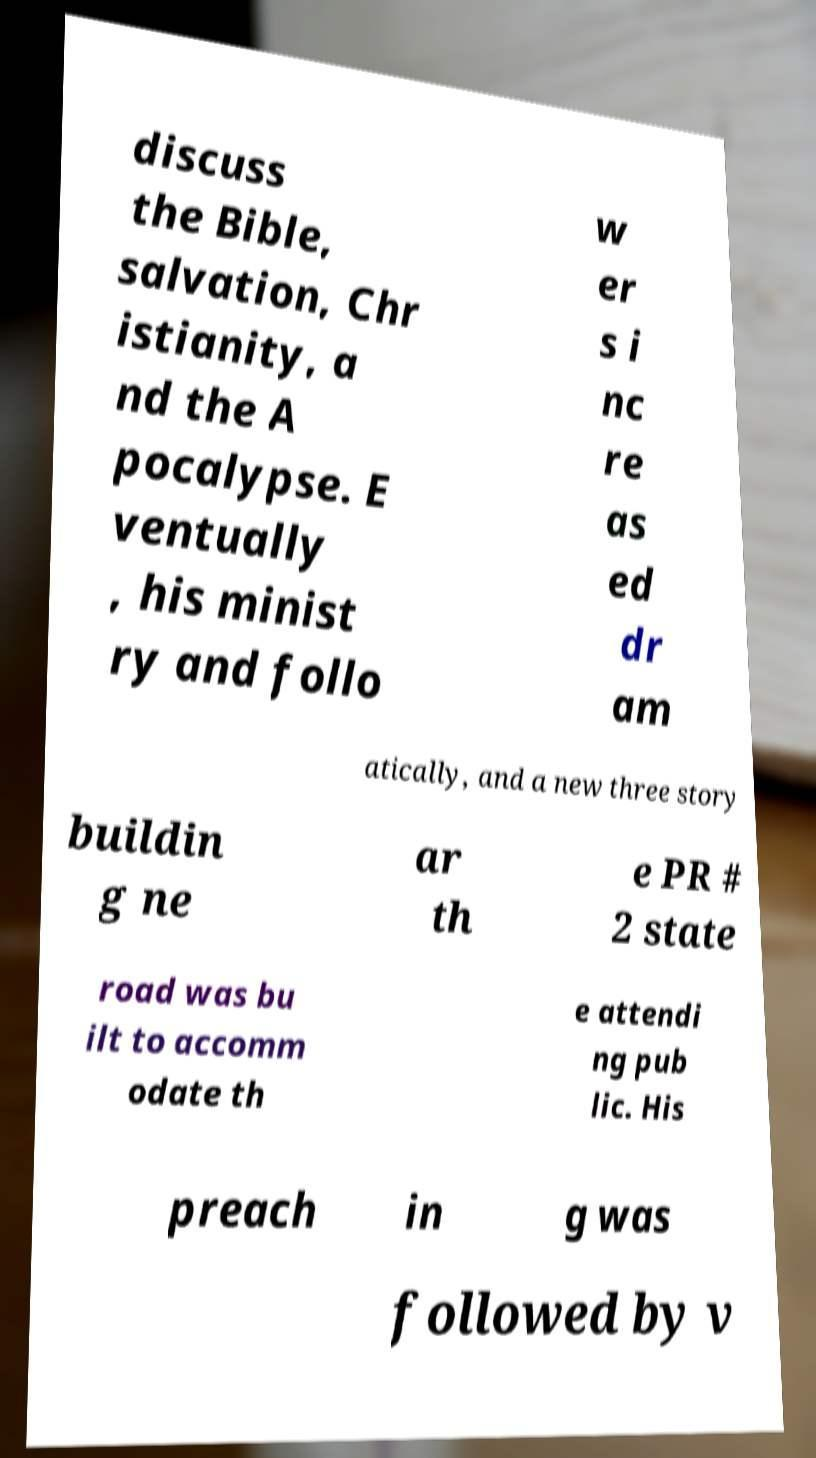For documentation purposes, I need the text within this image transcribed. Could you provide that? discuss the Bible, salvation, Chr istianity, a nd the A pocalypse. E ventually , his minist ry and follo w er s i nc re as ed dr am atically, and a new three story buildin g ne ar th e PR # 2 state road was bu ilt to accomm odate th e attendi ng pub lic. His preach in g was followed by v 